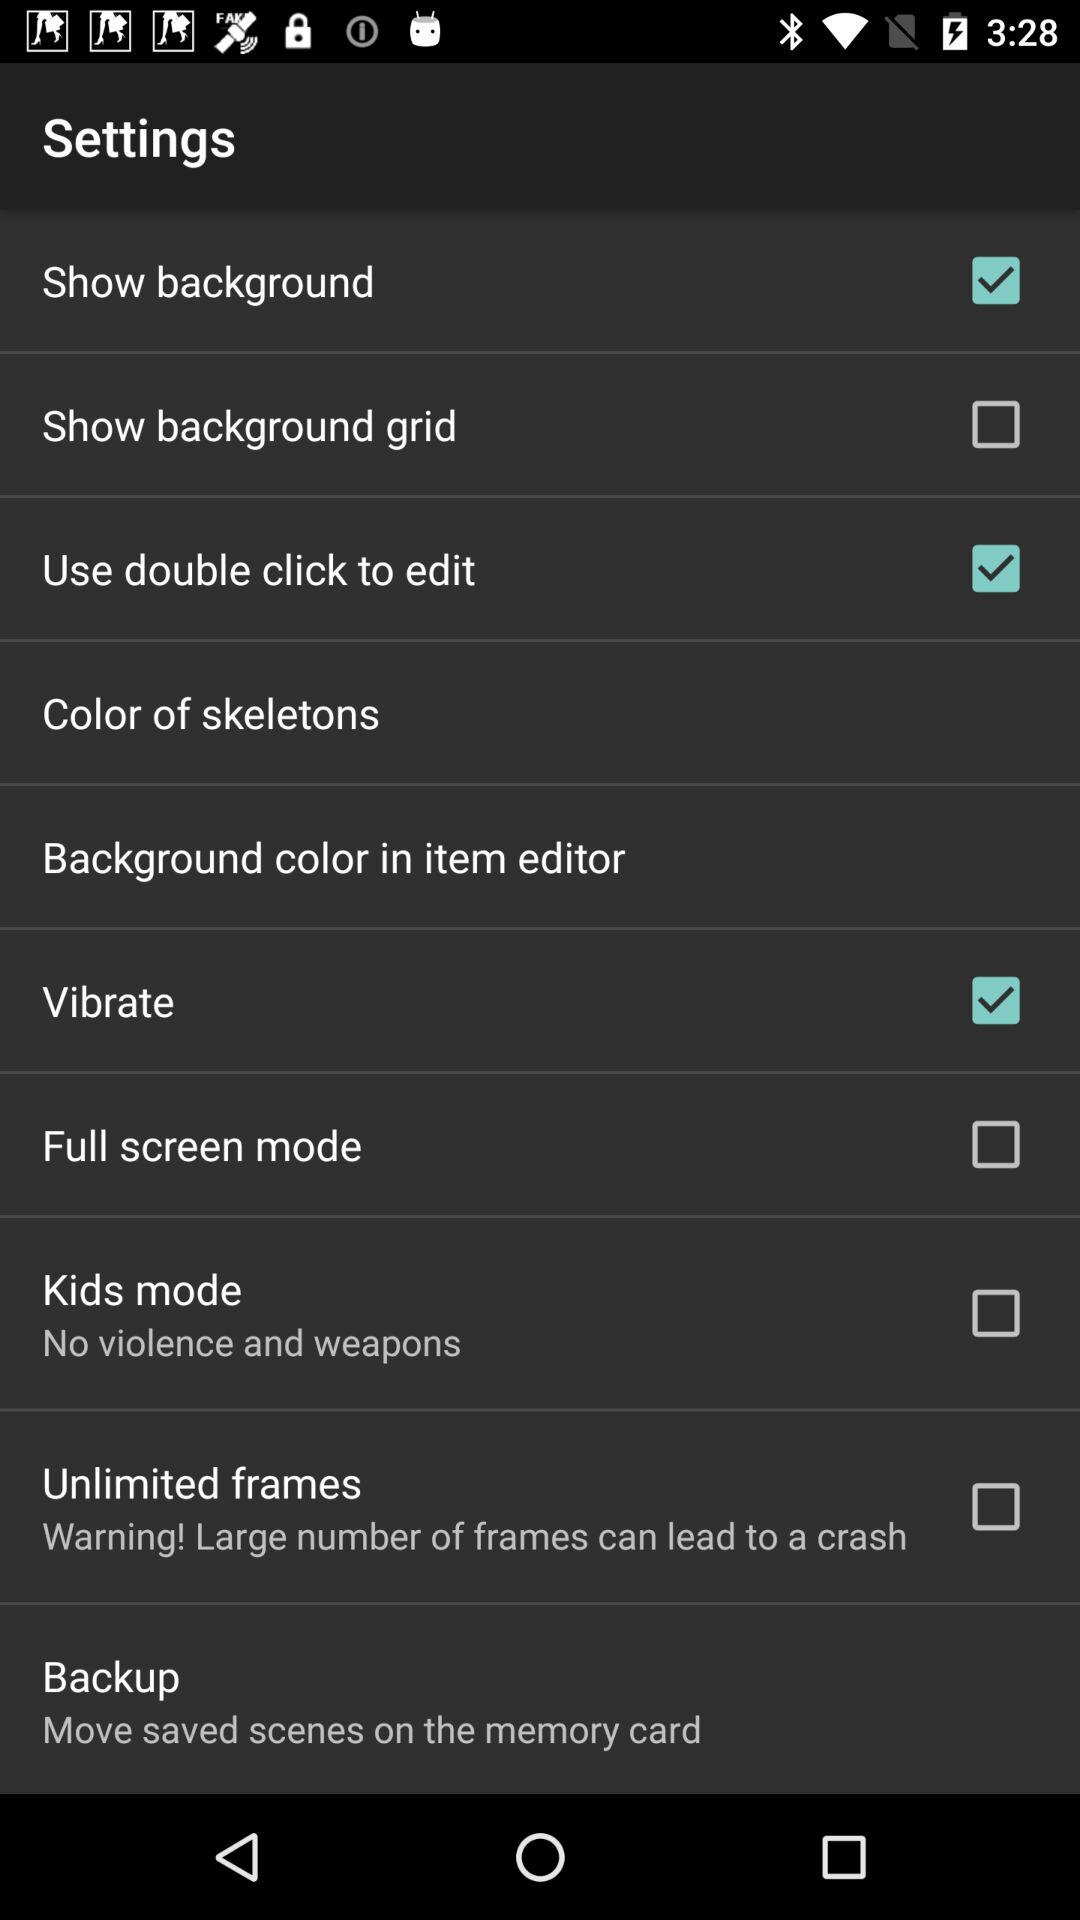What is the status of the vibrate? The status is on. 